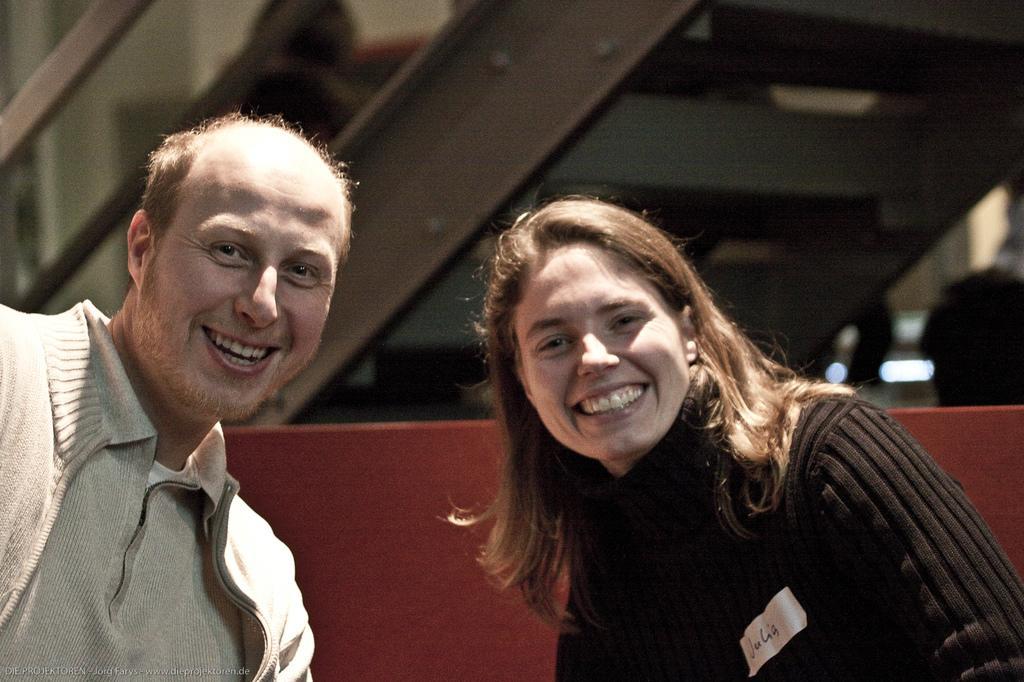Could you give a brief overview of what you see in this image? There are two people smiling. In the background it is blurry and we can see steps and railing. 